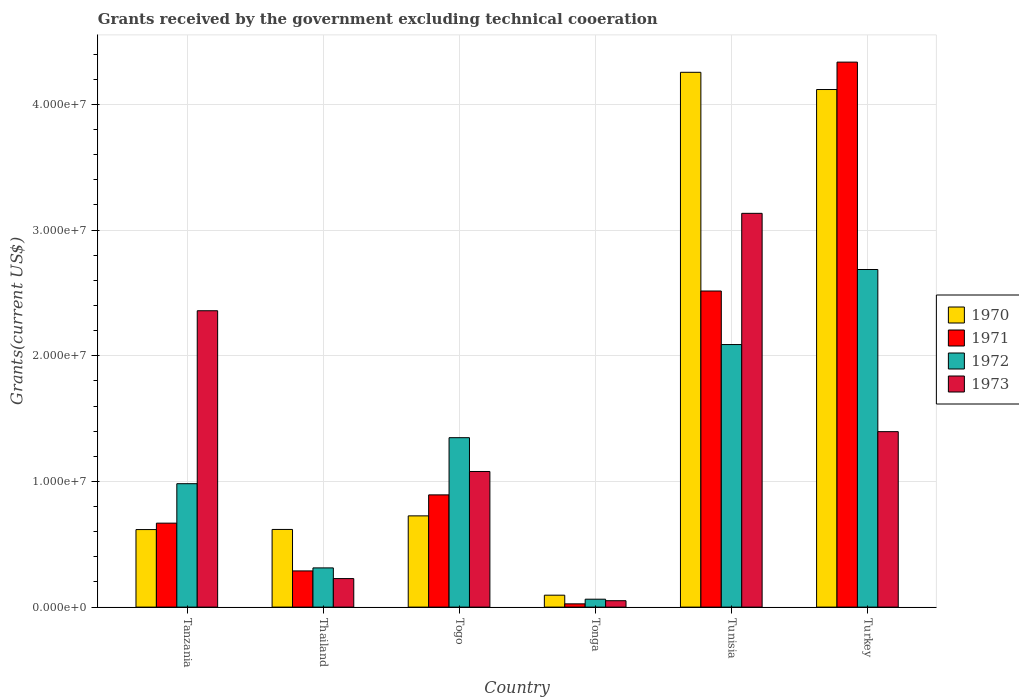How many groups of bars are there?
Your response must be concise. 6. Are the number of bars per tick equal to the number of legend labels?
Provide a short and direct response. Yes. What is the label of the 5th group of bars from the left?
Keep it short and to the point. Tunisia. What is the total grants received by the government in 1972 in Tunisia?
Your response must be concise. 2.09e+07. Across all countries, what is the maximum total grants received by the government in 1972?
Provide a succinct answer. 2.69e+07. Across all countries, what is the minimum total grants received by the government in 1970?
Your response must be concise. 9.50e+05. In which country was the total grants received by the government in 1970 minimum?
Provide a short and direct response. Tonga. What is the total total grants received by the government in 1972 in the graph?
Your response must be concise. 7.48e+07. What is the difference between the total grants received by the government in 1972 in Thailand and that in Tunisia?
Offer a very short reply. -1.78e+07. What is the difference between the total grants received by the government in 1973 in Tanzania and the total grants received by the government in 1972 in Togo?
Give a very brief answer. 1.01e+07. What is the average total grants received by the government in 1972 per country?
Offer a very short reply. 1.25e+07. What is the difference between the total grants received by the government of/in 1972 and total grants received by the government of/in 1971 in Turkey?
Your answer should be compact. -1.65e+07. What is the ratio of the total grants received by the government in 1972 in Tanzania to that in Togo?
Make the answer very short. 0.73. Is the total grants received by the government in 1972 in Thailand less than that in Tonga?
Provide a short and direct response. No. What is the difference between the highest and the second highest total grants received by the government in 1971?
Ensure brevity in your answer.  1.82e+07. What is the difference between the highest and the lowest total grants received by the government in 1971?
Provide a succinct answer. 4.31e+07. Is the sum of the total grants received by the government in 1972 in Tanzania and Turkey greater than the maximum total grants received by the government in 1973 across all countries?
Your answer should be very brief. Yes. Are all the bars in the graph horizontal?
Provide a succinct answer. No. What is the difference between two consecutive major ticks on the Y-axis?
Make the answer very short. 1.00e+07. Does the graph contain any zero values?
Your answer should be compact. No. Where does the legend appear in the graph?
Give a very brief answer. Center right. How many legend labels are there?
Ensure brevity in your answer.  4. How are the legend labels stacked?
Offer a terse response. Vertical. What is the title of the graph?
Offer a terse response. Grants received by the government excluding technical cooeration. What is the label or title of the Y-axis?
Your answer should be compact. Grants(current US$). What is the Grants(current US$) in 1970 in Tanzania?
Ensure brevity in your answer.  6.17e+06. What is the Grants(current US$) of 1971 in Tanzania?
Ensure brevity in your answer.  6.68e+06. What is the Grants(current US$) in 1972 in Tanzania?
Offer a very short reply. 9.82e+06. What is the Grants(current US$) of 1973 in Tanzania?
Your answer should be very brief. 2.36e+07. What is the Grants(current US$) in 1970 in Thailand?
Your response must be concise. 6.18e+06. What is the Grants(current US$) in 1971 in Thailand?
Make the answer very short. 2.88e+06. What is the Grants(current US$) in 1972 in Thailand?
Your answer should be very brief. 3.12e+06. What is the Grants(current US$) in 1973 in Thailand?
Keep it short and to the point. 2.27e+06. What is the Grants(current US$) of 1970 in Togo?
Make the answer very short. 7.26e+06. What is the Grants(current US$) of 1971 in Togo?
Give a very brief answer. 8.93e+06. What is the Grants(current US$) in 1972 in Togo?
Offer a terse response. 1.35e+07. What is the Grants(current US$) of 1973 in Togo?
Make the answer very short. 1.08e+07. What is the Grants(current US$) of 1970 in Tonga?
Make the answer very short. 9.50e+05. What is the Grants(current US$) of 1972 in Tonga?
Your answer should be very brief. 6.30e+05. What is the Grants(current US$) in 1973 in Tonga?
Ensure brevity in your answer.  5.10e+05. What is the Grants(current US$) of 1970 in Tunisia?
Your response must be concise. 4.26e+07. What is the Grants(current US$) of 1971 in Tunisia?
Offer a very short reply. 2.52e+07. What is the Grants(current US$) in 1972 in Tunisia?
Provide a short and direct response. 2.09e+07. What is the Grants(current US$) in 1973 in Tunisia?
Make the answer very short. 3.13e+07. What is the Grants(current US$) in 1970 in Turkey?
Make the answer very short. 4.12e+07. What is the Grants(current US$) of 1971 in Turkey?
Your answer should be very brief. 4.34e+07. What is the Grants(current US$) of 1972 in Turkey?
Your answer should be very brief. 2.69e+07. What is the Grants(current US$) of 1973 in Turkey?
Offer a very short reply. 1.40e+07. Across all countries, what is the maximum Grants(current US$) of 1970?
Your answer should be very brief. 4.26e+07. Across all countries, what is the maximum Grants(current US$) of 1971?
Your response must be concise. 4.34e+07. Across all countries, what is the maximum Grants(current US$) in 1972?
Make the answer very short. 2.69e+07. Across all countries, what is the maximum Grants(current US$) of 1973?
Offer a terse response. 3.13e+07. Across all countries, what is the minimum Grants(current US$) of 1970?
Keep it short and to the point. 9.50e+05. Across all countries, what is the minimum Grants(current US$) of 1971?
Make the answer very short. 2.60e+05. Across all countries, what is the minimum Grants(current US$) of 1972?
Provide a succinct answer. 6.30e+05. Across all countries, what is the minimum Grants(current US$) in 1973?
Your response must be concise. 5.10e+05. What is the total Grants(current US$) in 1970 in the graph?
Offer a very short reply. 1.04e+08. What is the total Grants(current US$) of 1971 in the graph?
Offer a terse response. 8.73e+07. What is the total Grants(current US$) of 1972 in the graph?
Make the answer very short. 7.48e+07. What is the total Grants(current US$) of 1973 in the graph?
Provide a succinct answer. 8.24e+07. What is the difference between the Grants(current US$) in 1970 in Tanzania and that in Thailand?
Your response must be concise. -10000. What is the difference between the Grants(current US$) of 1971 in Tanzania and that in Thailand?
Provide a short and direct response. 3.80e+06. What is the difference between the Grants(current US$) of 1972 in Tanzania and that in Thailand?
Offer a terse response. 6.70e+06. What is the difference between the Grants(current US$) of 1973 in Tanzania and that in Thailand?
Your response must be concise. 2.13e+07. What is the difference between the Grants(current US$) of 1970 in Tanzania and that in Togo?
Provide a succinct answer. -1.09e+06. What is the difference between the Grants(current US$) in 1971 in Tanzania and that in Togo?
Offer a terse response. -2.25e+06. What is the difference between the Grants(current US$) in 1972 in Tanzania and that in Togo?
Offer a terse response. -3.66e+06. What is the difference between the Grants(current US$) of 1973 in Tanzania and that in Togo?
Provide a short and direct response. 1.28e+07. What is the difference between the Grants(current US$) of 1970 in Tanzania and that in Tonga?
Offer a terse response. 5.22e+06. What is the difference between the Grants(current US$) of 1971 in Tanzania and that in Tonga?
Your answer should be compact. 6.42e+06. What is the difference between the Grants(current US$) of 1972 in Tanzania and that in Tonga?
Your response must be concise. 9.19e+06. What is the difference between the Grants(current US$) in 1973 in Tanzania and that in Tonga?
Offer a very short reply. 2.31e+07. What is the difference between the Grants(current US$) in 1970 in Tanzania and that in Tunisia?
Provide a succinct answer. -3.64e+07. What is the difference between the Grants(current US$) of 1971 in Tanzania and that in Tunisia?
Your answer should be very brief. -1.85e+07. What is the difference between the Grants(current US$) of 1972 in Tanzania and that in Tunisia?
Keep it short and to the point. -1.11e+07. What is the difference between the Grants(current US$) in 1973 in Tanzania and that in Tunisia?
Ensure brevity in your answer.  -7.75e+06. What is the difference between the Grants(current US$) in 1970 in Tanzania and that in Turkey?
Your answer should be compact. -3.50e+07. What is the difference between the Grants(current US$) of 1971 in Tanzania and that in Turkey?
Provide a succinct answer. -3.67e+07. What is the difference between the Grants(current US$) of 1972 in Tanzania and that in Turkey?
Your response must be concise. -1.70e+07. What is the difference between the Grants(current US$) in 1973 in Tanzania and that in Turkey?
Your response must be concise. 9.62e+06. What is the difference between the Grants(current US$) of 1970 in Thailand and that in Togo?
Make the answer very short. -1.08e+06. What is the difference between the Grants(current US$) in 1971 in Thailand and that in Togo?
Give a very brief answer. -6.05e+06. What is the difference between the Grants(current US$) in 1972 in Thailand and that in Togo?
Give a very brief answer. -1.04e+07. What is the difference between the Grants(current US$) of 1973 in Thailand and that in Togo?
Provide a short and direct response. -8.52e+06. What is the difference between the Grants(current US$) of 1970 in Thailand and that in Tonga?
Make the answer very short. 5.23e+06. What is the difference between the Grants(current US$) in 1971 in Thailand and that in Tonga?
Give a very brief answer. 2.62e+06. What is the difference between the Grants(current US$) of 1972 in Thailand and that in Tonga?
Provide a short and direct response. 2.49e+06. What is the difference between the Grants(current US$) in 1973 in Thailand and that in Tonga?
Your response must be concise. 1.76e+06. What is the difference between the Grants(current US$) in 1970 in Thailand and that in Tunisia?
Provide a short and direct response. -3.64e+07. What is the difference between the Grants(current US$) in 1971 in Thailand and that in Tunisia?
Your answer should be compact. -2.23e+07. What is the difference between the Grants(current US$) of 1972 in Thailand and that in Tunisia?
Keep it short and to the point. -1.78e+07. What is the difference between the Grants(current US$) of 1973 in Thailand and that in Tunisia?
Offer a terse response. -2.91e+07. What is the difference between the Grants(current US$) of 1970 in Thailand and that in Turkey?
Give a very brief answer. -3.50e+07. What is the difference between the Grants(current US$) of 1971 in Thailand and that in Turkey?
Your answer should be compact. -4.05e+07. What is the difference between the Grants(current US$) in 1972 in Thailand and that in Turkey?
Ensure brevity in your answer.  -2.37e+07. What is the difference between the Grants(current US$) of 1973 in Thailand and that in Turkey?
Your response must be concise. -1.17e+07. What is the difference between the Grants(current US$) of 1970 in Togo and that in Tonga?
Provide a short and direct response. 6.31e+06. What is the difference between the Grants(current US$) of 1971 in Togo and that in Tonga?
Your response must be concise. 8.67e+06. What is the difference between the Grants(current US$) of 1972 in Togo and that in Tonga?
Your answer should be compact. 1.28e+07. What is the difference between the Grants(current US$) of 1973 in Togo and that in Tonga?
Make the answer very short. 1.03e+07. What is the difference between the Grants(current US$) in 1970 in Togo and that in Tunisia?
Provide a short and direct response. -3.53e+07. What is the difference between the Grants(current US$) in 1971 in Togo and that in Tunisia?
Offer a terse response. -1.62e+07. What is the difference between the Grants(current US$) of 1972 in Togo and that in Tunisia?
Ensure brevity in your answer.  -7.41e+06. What is the difference between the Grants(current US$) in 1973 in Togo and that in Tunisia?
Offer a very short reply. -2.05e+07. What is the difference between the Grants(current US$) in 1970 in Togo and that in Turkey?
Make the answer very short. -3.39e+07. What is the difference between the Grants(current US$) of 1971 in Togo and that in Turkey?
Your answer should be compact. -3.44e+07. What is the difference between the Grants(current US$) of 1972 in Togo and that in Turkey?
Make the answer very short. -1.34e+07. What is the difference between the Grants(current US$) of 1973 in Togo and that in Turkey?
Your answer should be compact. -3.17e+06. What is the difference between the Grants(current US$) in 1970 in Tonga and that in Tunisia?
Offer a terse response. -4.16e+07. What is the difference between the Grants(current US$) in 1971 in Tonga and that in Tunisia?
Your answer should be very brief. -2.49e+07. What is the difference between the Grants(current US$) of 1972 in Tonga and that in Tunisia?
Offer a terse response. -2.03e+07. What is the difference between the Grants(current US$) in 1973 in Tonga and that in Tunisia?
Your answer should be very brief. -3.08e+07. What is the difference between the Grants(current US$) of 1970 in Tonga and that in Turkey?
Provide a succinct answer. -4.02e+07. What is the difference between the Grants(current US$) of 1971 in Tonga and that in Turkey?
Ensure brevity in your answer.  -4.31e+07. What is the difference between the Grants(current US$) in 1972 in Tonga and that in Turkey?
Offer a terse response. -2.62e+07. What is the difference between the Grants(current US$) in 1973 in Tonga and that in Turkey?
Give a very brief answer. -1.34e+07. What is the difference between the Grants(current US$) of 1970 in Tunisia and that in Turkey?
Provide a short and direct response. 1.37e+06. What is the difference between the Grants(current US$) in 1971 in Tunisia and that in Turkey?
Provide a short and direct response. -1.82e+07. What is the difference between the Grants(current US$) in 1972 in Tunisia and that in Turkey?
Provide a short and direct response. -5.97e+06. What is the difference between the Grants(current US$) of 1973 in Tunisia and that in Turkey?
Make the answer very short. 1.74e+07. What is the difference between the Grants(current US$) of 1970 in Tanzania and the Grants(current US$) of 1971 in Thailand?
Give a very brief answer. 3.29e+06. What is the difference between the Grants(current US$) of 1970 in Tanzania and the Grants(current US$) of 1972 in Thailand?
Your answer should be very brief. 3.05e+06. What is the difference between the Grants(current US$) in 1970 in Tanzania and the Grants(current US$) in 1973 in Thailand?
Offer a terse response. 3.90e+06. What is the difference between the Grants(current US$) of 1971 in Tanzania and the Grants(current US$) of 1972 in Thailand?
Your response must be concise. 3.56e+06. What is the difference between the Grants(current US$) of 1971 in Tanzania and the Grants(current US$) of 1973 in Thailand?
Offer a terse response. 4.41e+06. What is the difference between the Grants(current US$) in 1972 in Tanzania and the Grants(current US$) in 1973 in Thailand?
Offer a terse response. 7.55e+06. What is the difference between the Grants(current US$) of 1970 in Tanzania and the Grants(current US$) of 1971 in Togo?
Provide a short and direct response. -2.76e+06. What is the difference between the Grants(current US$) of 1970 in Tanzania and the Grants(current US$) of 1972 in Togo?
Make the answer very short. -7.31e+06. What is the difference between the Grants(current US$) of 1970 in Tanzania and the Grants(current US$) of 1973 in Togo?
Your answer should be compact. -4.62e+06. What is the difference between the Grants(current US$) of 1971 in Tanzania and the Grants(current US$) of 1972 in Togo?
Offer a very short reply. -6.80e+06. What is the difference between the Grants(current US$) in 1971 in Tanzania and the Grants(current US$) in 1973 in Togo?
Your answer should be very brief. -4.11e+06. What is the difference between the Grants(current US$) of 1972 in Tanzania and the Grants(current US$) of 1973 in Togo?
Offer a very short reply. -9.70e+05. What is the difference between the Grants(current US$) of 1970 in Tanzania and the Grants(current US$) of 1971 in Tonga?
Your response must be concise. 5.91e+06. What is the difference between the Grants(current US$) of 1970 in Tanzania and the Grants(current US$) of 1972 in Tonga?
Make the answer very short. 5.54e+06. What is the difference between the Grants(current US$) of 1970 in Tanzania and the Grants(current US$) of 1973 in Tonga?
Give a very brief answer. 5.66e+06. What is the difference between the Grants(current US$) in 1971 in Tanzania and the Grants(current US$) in 1972 in Tonga?
Offer a very short reply. 6.05e+06. What is the difference between the Grants(current US$) of 1971 in Tanzania and the Grants(current US$) of 1973 in Tonga?
Ensure brevity in your answer.  6.17e+06. What is the difference between the Grants(current US$) in 1972 in Tanzania and the Grants(current US$) in 1973 in Tonga?
Offer a terse response. 9.31e+06. What is the difference between the Grants(current US$) of 1970 in Tanzania and the Grants(current US$) of 1971 in Tunisia?
Your response must be concise. -1.90e+07. What is the difference between the Grants(current US$) of 1970 in Tanzania and the Grants(current US$) of 1972 in Tunisia?
Make the answer very short. -1.47e+07. What is the difference between the Grants(current US$) of 1970 in Tanzania and the Grants(current US$) of 1973 in Tunisia?
Offer a terse response. -2.52e+07. What is the difference between the Grants(current US$) of 1971 in Tanzania and the Grants(current US$) of 1972 in Tunisia?
Offer a very short reply. -1.42e+07. What is the difference between the Grants(current US$) of 1971 in Tanzania and the Grants(current US$) of 1973 in Tunisia?
Your answer should be compact. -2.46e+07. What is the difference between the Grants(current US$) of 1972 in Tanzania and the Grants(current US$) of 1973 in Tunisia?
Your answer should be compact. -2.15e+07. What is the difference between the Grants(current US$) in 1970 in Tanzania and the Grants(current US$) in 1971 in Turkey?
Your response must be concise. -3.72e+07. What is the difference between the Grants(current US$) in 1970 in Tanzania and the Grants(current US$) in 1972 in Turkey?
Give a very brief answer. -2.07e+07. What is the difference between the Grants(current US$) in 1970 in Tanzania and the Grants(current US$) in 1973 in Turkey?
Offer a terse response. -7.79e+06. What is the difference between the Grants(current US$) of 1971 in Tanzania and the Grants(current US$) of 1972 in Turkey?
Offer a very short reply. -2.02e+07. What is the difference between the Grants(current US$) in 1971 in Tanzania and the Grants(current US$) in 1973 in Turkey?
Provide a succinct answer. -7.28e+06. What is the difference between the Grants(current US$) of 1972 in Tanzania and the Grants(current US$) of 1973 in Turkey?
Offer a very short reply. -4.14e+06. What is the difference between the Grants(current US$) of 1970 in Thailand and the Grants(current US$) of 1971 in Togo?
Your answer should be compact. -2.75e+06. What is the difference between the Grants(current US$) of 1970 in Thailand and the Grants(current US$) of 1972 in Togo?
Your answer should be compact. -7.30e+06. What is the difference between the Grants(current US$) of 1970 in Thailand and the Grants(current US$) of 1973 in Togo?
Provide a short and direct response. -4.61e+06. What is the difference between the Grants(current US$) of 1971 in Thailand and the Grants(current US$) of 1972 in Togo?
Your response must be concise. -1.06e+07. What is the difference between the Grants(current US$) in 1971 in Thailand and the Grants(current US$) in 1973 in Togo?
Your answer should be compact. -7.91e+06. What is the difference between the Grants(current US$) in 1972 in Thailand and the Grants(current US$) in 1973 in Togo?
Make the answer very short. -7.67e+06. What is the difference between the Grants(current US$) of 1970 in Thailand and the Grants(current US$) of 1971 in Tonga?
Make the answer very short. 5.92e+06. What is the difference between the Grants(current US$) in 1970 in Thailand and the Grants(current US$) in 1972 in Tonga?
Provide a short and direct response. 5.55e+06. What is the difference between the Grants(current US$) in 1970 in Thailand and the Grants(current US$) in 1973 in Tonga?
Your answer should be very brief. 5.67e+06. What is the difference between the Grants(current US$) in 1971 in Thailand and the Grants(current US$) in 1972 in Tonga?
Offer a very short reply. 2.25e+06. What is the difference between the Grants(current US$) of 1971 in Thailand and the Grants(current US$) of 1973 in Tonga?
Provide a short and direct response. 2.37e+06. What is the difference between the Grants(current US$) of 1972 in Thailand and the Grants(current US$) of 1973 in Tonga?
Your answer should be very brief. 2.61e+06. What is the difference between the Grants(current US$) in 1970 in Thailand and the Grants(current US$) in 1971 in Tunisia?
Ensure brevity in your answer.  -1.90e+07. What is the difference between the Grants(current US$) of 1970 in Thailand and the Grants(current US$) of 1972 in Tunisia?
Make the answer very short. -1.47e+07. What is the difference between the Grants(current US$) of 1970 in Thailand and the Grants(current US$) of 1973 in Tunisia?
Provide a short and direct response. -2.52e+07. What is the difference between the Grants(current US$) in 1971 in Thailand and the Grants(current US$) in 1972 in Tunisia?
Offer a very short reply. -1.80e+07. What is the difference between the Grants(current US$) in 1971 in Thailand and the Grants(current US$) in 1973 in Tunisia?
Your answer should be compact. -2.84e+07. What is the difference between the Grants(current US$) in 1972 in Thailand and the Grants(current US$) in 1973 in Tunisia?
Give a very brief answer. -2.82e+07. What is the difference between the Grants(current US$) in 1970 in Thailand and the Grants(current US$) in 1971 in Turkey?
Keep it short and to the point. -3.72e+07. What is the difference between the Grants(current US$) in 1970 in Thailand and the Grants(current US$) in 1972 in Turkey?
Your response must be concise. -2.07e+07. What is the difference between the Grants(current US$) of 1970 in Thailand and the Grants(current US$) of 1973 in Turkey?
Provide a succinct answer. -7.78e+06. What is the difference between the Grants(current US$) of 1971 in Thailand and the Grants(current US$) of 1972 in Turkey?
Make the answer very short. -2.40e+07. What is the difference between the Grants(current US$) in 1971 in Thailand and the Grants(current US$) in 1973 in Turkey?
Give a very brief answer. -1.11e+07. What is the difference between the Grants(current US$) in 1972 in Thailand and the Grants(current US$) in 1973 in Turkey?
Offer a very short reply. -1.08e+07. What is the difference between the Grants(current US$) of 1970 in Togo and the Grants(current US$) of 1971 in Tonga?
Your answer should be very brief. 7.00e+06. What is the difference between the Grants(current US$) in 1970 in Togo and the Grants(current US$) in 1972 in Tonga?
Ensure brevity in your answer.  6.63e+06. What is the difference between the Grants(current US$) of 1970 in Togo and the Grants(current US$) of 1973 in Tonga?
Your answer should be very brief. 6.75e+06. What is the difference between the Grants(current US$) of 1971 in Togo and the Grants(current US$) of 1972 in Tonga?
Offer a terse response. 8.30e+06. What is the difference between the Grants(current US$) in 1971 in Togo and the Grants(current US$) in 1973 in Tonga?
Your response must be concise. 8.42e+06. What is the difference between the Grants(current US$) of 1972 in Togo and the Grants(current US$) of 1973 in Tonga?
Provide a short and direct response. 1.30e+07. What is the difference between the Grants(current US$) in 1970 in Togo and the Grants(current US$) in 1971 in Tunisia?
Give a very brief answer. -1.79e+07. What is the difference between the Grants(current US$) in 1970 in Togo and the Grants(current US$) in 1972 in Tunisia?
Offer a very short reply. -1.36e+07. What is the difference between the Grants(current US$) in 1970 in Togo and the Grants(current US$) in 1973 in Tunisia?
Provide a short and direct response. -2.41e+07. What is the difference between the Grants(current US$) of 1971 in Togo and the Grants(current US$) of 1972 in Tunisia?
Keep it short and to the point. -1.20e+07. What is the difference between the Grants(current US$) of 1971 in Togo and the Grants(current US$) of 1973 in Tunisia?
Ensure brevity in your answer.  -2.24e+07. What is the difference between the Grants(current US$) of 1972 in Togo and the Grants(current US$) of 1973 in Tunisia?
Your answer should be very brief. -1.78e+07. What is the difference between the Grants(current US$) in 1970 in Togo and the Grants(current US$) in 1971 in Turkey?
Provide a short and direct response. -3.61e+07. What is the difference between the Grants(current US$) of 1970 in Togo and the Grants(current US$) of 1972 in Turkey?
Ensure brevity in your answer.  -1.96e+07. What is the difference between the Grants(current US$) in 1970 in Togo and the Grants(current US$) in 1973 in Turkey?
Ensure brevity in your answer.  -6.70e+06. What is the difference between the Grants(current US$) in 1971 in Togo and the Grants(current US$) in 1972 in Turkey?
Give a very brief answer. -1.79e+07. What is the difference between the Grants(current US$) in 1971 in Togo and the Grants(current US$) in 1973 in Turkey?
Offer a very short reply. -5.03e+06. What is the difference between the Grants(current US$) of 1972 in Togo and the Grants(current US$) of 1973 in Turkey?
Keep it short and to the point. -4.80e+05. What is the difference between the Grants(current US$) of 1970 in Tonga and the Grants(current US$) of 1971 in Tunisia?
Make the answer very short. -2.42e+07. What is the difference between the Grants(current US$) of 1970 in Tonga and the Grants(current US$) of 1972 in Tunisia?
Make the answer very short. -1.99e+07. What is the difference between the Grants(current US$) of 1970 in Tonga and the Grants(current US$) of 1973 in Tunisia?
Make the answer very short. -3.04e+07. What is the difference between the Grants(current US$) in 1971 in Tonga and the Grants(current US$) in 1972 in Tunisia?
Ensure brevity in your answer.  -2.06e+07. What is the difference between the Grants(current US$) of 1971 in Tonga and the Grants(current US$) of 1973 in Tunisia?
Offer a very short reply. -3.11e+07. What is the difference between the Grants(current US$) in 1972 in Tonga and the Grants(current US$) in 1973 in Tunisia?
Provide a succinct answer. -3.07e+07. What is the difference between the Grants(current US$) of 1970 in Tonga and the Grants(current US$) of 1971 in Turkey?
Your response must be concise. -4.24e+07. What is the difference between the Grants(current US$) of 1970 in Tonga and the Grants(current US$) of 1972 in Turkey?
Offer a terse response. -2.59e+07. What is the difference between the Grants(current US$) of 1970 in Tonga and the Grants(current US$) of 1973 in Turkey?
Your response must be concise. -1.30e+07. What is the difference between the Grants(current US$) in 1971 in Tonga and the Grants(current US$) in 1972 in Turkey?
Make the answer very short. -2.66e+07. What is the difference between the Grants(current US$) of 1971 in Tonga and the Grants(current US$) of 1973 in Turkey?
Your answer should be very brief. -1.37e+07. What is the difference between the Grants(current US$) in 1972 in Tonga and the Grants(current US$) in 1973 in Turkey?
Ensure brevity in your answer.  -1.33e+07. What is the difference between the Grants(current US$) of 1970 in Tunisia and the Grants(current US$) of 1971 in Turkey?
Your answer should be very brief. -8.10e+05. What is the difference between the Grants(current US$) of 1970 in Tunisia and the Grants(current US$) of 1972 in Turkey?
Offer a terse response. 1.57e+07. What is the difference between the Grants(current US$) of 1970 in Tunisia and the Grants(current US$) of 1973 in Turkey?
Offer a terse response. 2.86e+07. What is the difference between the Grants(current US$) of 1971 in Tunisia and the Grants(current US$) of 1972 in Turkey?
Your response must be concise. -1.71e+06. What is the difference between the Grants(current US$) of 1971 in Tunisia and the Grants(current US$) of 1973 in Turkey?
Offer a very short reply. 1.12e+07. What is the difference between the Grants(current US$) in 1972 in Tunisia and the Grants(current US$) in 1973 in Turkey?
Your answer should be very brief. 6.93e+06. What is the average Grants(current US$) in 1970 per country?
Keep it short and to the point. 1.74e+07. What is the average Grants(current US$) in 1971 per country?
Give a very brief answer. 1.45e+07. What is the average Grants(current US$) in 1972 per country?
Your answer should be very brief. 1.25e+07. What is the average Grants(current US$) of 1973 per country?
Your response must be concise. 1.37e+07. What is the difference between the Grants(current US$) in 1970 and Grants(current US$) in 1971 in Tanzania?
Your response must be concise. -5.10e+05. What is the difference between the Grants(current US$) of 1970 and Grants(current US$) of 1972 in Tanzania?
Keep it short and to the point. -3.65e+06. What is the difference between the Grants(current US$) in 1970 and Grants(current US$) in 1973 in Tanzania?
Ensure brevity in your answer.  -1.74e+07. What is the difference between the Grants(current US$) of 1971 and Grants(current US$) of 1972 in Tanzania?
Give a very brief answer. -3.14e+06. What is the difference between the Grants(current US$) in 1971 and Grants(current US$) in 1973 in Tanzania?
Your answer should be compact. -1.69e+07. What is the difference between the Grants(current US$) in 1972 and Grants(current US$) in 1973 in Tanzania?
Provide a succinct answer. -1.38e+07. What is the difference between the Grants(current US$) of 1970 and Grants(current US$) of 1971 in Thailand?
Your answer should be compact. 3.30e+06. What is the difference between the Grants(current US$) of 1970 and Grants(current US$) of 1972 in Thailand?
Your response must be concise. 3.06e+06. What is the difference between the Grants(current US$) in 1970 and Grants(current US$) in 1973 in Thailand?
Your answer should be very brief. 3.91e+06. What is the difference between the Grants(current US$) of 1972 and Grants(current US$) of 1973 in Thailand?
Offer a very short reply. 8.50e+05. What is the difference between the Grants(current US$) in 1970 and Grants(current US$) in 1971 in Togo?
Your answer should be compact. -1.67e+06. What is the difference between the Grants(current US$) of 1970 and Grants(current US$) of 1972 in Togo?
Keep it short and to the point. -6.22e+06. What is the difference between the Grants(current US$) of 1970 and Grants(current US$) of 1973 in Togo?
Offer a very short reply. -3.53e+06. What is the difference between the Grants(current US$) in 1971 and Grants(current US$) in 1972 in Togo?
Keep it short and to the point. -4.55e+06. What is the difference between the Grants(current US$) of 1971 and Grants(current US$) of 1973 in Togo?
Make the answer very short. -1.86e+06. What is the difference between the Grants(current US$) of 1972 and Grants(current US$) of 1973 in Togo?
Offer a very short reply. 2.69e+06. What is the difference between the Grants(current US$) of 1970 and Grants(current US$) of 1971 in Tonga?
Provide a short and direct response. 6.90e+05. What is the difference between the Grants(current US$) of 1970 and Grants(current US$) of 1973 in Tonga?
Give a very brief answer. 4.40e+05. What is the difference between the Grants(current US$) in 1971 and Grants(current US$) in 1972 in Tonga?
Keep it short and to the point. -3.70e+05. What is the difference between the Grants(current US$) in 1971 and Grants(current US$) in 1973 in Tonga?
Offer a very short reply. -2.50e+05. What is the difference between the Grants(current US$) in 1972 and Grants(current US$) in 1973 in Tonga?
Your response must be concise. 1.20e+05. What is the difference between the Grants(current US$) in 1970 and Grants(current US$) in 1971 in Tunisia?
Offer a very short reply. 1.74e+07. What is the difference between the Grants(current US$) of 1970 and Grants(current US$) of 1972 in Tunisia?
Ensure brevity in your answer.  2.17e+07. What is the difference between the Grants(current US$) of 1970 and Grants(current US$) of 1973 in Tunisia?
Ensure brevity in your answer.  1.12e+07. What is the difference between the Grants(current US$) of 1971 and Grants(current US$) of 1972 in Tunisia?
Give a very brief answer. 4.26e+06. What is the difference between the Grants(current US$) in 1971 and Grants(current US$) in 1973 in Tunisia?
Your answer should be compact. -6.18e+06. What is the difference between the Grants(current US$) in 1972 and Grants(current US$) in 1973 in Tunisia?
Offer a very short reply. -1.04e+07. What is the difference between the Grants(current US$) of 1970 and Grants(current US$) of 1971 in Turkey?
Offer a terse response. -2.18e+06. What is the difference between the Grants(current US$) of 1970 and Grants(current US$) of 1972 in Turkey?
Ensure brevity in your answer.  1.43e+07. What is the difference between the Grants(current US$) in 1970 and Grants(current US$) in 1973 in Turkey?
Your response must be concise. 2.72e+07. What is the difference between the Grants(current US$) in 1971 and Grants(current US$) in 1972 in Turkey?
Your answer should be very brief. 1.65e+07. What is the difference between the Grants(current US$) of 1971 and Grants(current US$) of 1973 in Turkey?
Ensure brevity in your answer.  2.94e+07. What is the difference between the Grants(current US$) of 1972 and Grants(current US$) of 1973 in Turkey?
Provide a short and direct response. 1.29e+07. What is the ratio of the Grants(current US$) in 1971 in Tanzania to that in Thailand?
Ensure brevity in your answer.  2.32. What is the ratio of the Grants(current US$) of 1972 in Tanzania to that in Thailand?
Make the answer very short. 3.15. What is the ratio of the Grants(current US$) of 1973 in Tanzania to that in Thailand?
Your answer should be compact. 10.39. What is the ratio of the Grants(current US$) of 1970 in Tanzania to that in Togo?
Provide a short and direct response. 0.85. What is the ratio of the Grants(current US$) of 1971 in Tanzania to that in Togo?
Offer a terse response. 0.75. What is the ratio of the Grants(current US$) in 1972 in Tanzania to that in Togo?
Offer a very short reply. 0.73. What is the ratio of the Grants(current US$) of 1973 in Tanzania to that in Togo?
Make the answer very short. 2.19. What is the ratio of the Grants(current US$) of 1970 in Tanzania to that in Tonga?
Your answer should be very brief. 6.49. What is the ratio of the Grants(current US$) of 1971 in Tanzania to that in Tonga?
Provide a short and direct response. 25.69. What is the ratio of the Grants(current US$) in 1972 in Tanzania to that in Tonga?
Your answer should be compact. 15.59. What is the ratio of the Grants(current US$) of 1973 in Tanzania to that in Tonga?
Your answer should be very brief. 46.24. What is the ratio of the Grants(current US$) of 1970 in Tanzania to that in Tunisia?
Offer a terse response. 0.14. What is the ratio of the Grants(current US$) of 1971 in Tanzania to that in Tunisia?
Offer a very short reply. 0.27. What is the ratio of the Grants(current US$) of 1972 in Tanzania to that in Tunisia?
Your answer should be compact. 0.47. What is the ratio of the Grants(current US$) of 1973 in Tanzania to that in Tunisia?
Your response must be concise. 0.75. What is the ratio of the Grants(current US$) in 1970 in Tanzania to that in Turkey?
Your answer should be very brief. 0.15. What is the ratio of the Grants(current US$) in 1971 in Tanzania to that in Turkey?
Your response must be concise. 0.15. What is the ratio of the Grants(current US$) in 1972 in Tanzania to that in Turkey?
Your answer should be compact. 0.37. What is the ratio of the Grants(current US$) of 1973 in Tanzania to that in Turkey?
Your response must be concise. 1.69. What is the ratio of the Grants(current US$) of 1970 in Thailand to that in Togo?
Ensure brevity in your answer.  0.85. What is the ratio of the Grants(current US$) in 1971 in Thailand to that in Togo?
Offer a terse response. 0.32. What is the ratio of the Grants(current US$) in 1972 in Thailand to that in Togo?
Keep it short and to the point. 0.23. What is the ratio of the Grants(current US$) of 1973 in Thailand to that in Togo?
Your answer should be very brief. 0.21. What is the ratio of the Grants(current US$) of 1970 in Thailand to that in Tonga?
Your answer should be very brief. 6.51. What is the ratio of the Grants(current US$) in 1971 in Thailand to that in Tonga?
Make the answer very short. 11.08. What is the ratio of the Grants(current US$) of 1972 in Thailand to that in Tonga?
Your answer should be compact. 4.95. What is the ratio of the Grants(current US$) in 1973 in Thailand to that in Tonga?
Make the answer very short. 4.45. What is the ratio of the Grants(current US$) of 1970 in Thailand to that in Tunisia?
Your answer should be very brief. 0.15. What is the ratio of the Grants(current US$) of 1971 in Thailand to that in Tunisia?
Give a very brief answer. 0.11. What is the ratio of the Grants(current US$) of 1972 in Thailand to that in Tunisia?
Your answer should be very brief. 0.15. What is the ratio of the Grants(current US$) of 1973 in Thailand to that in Tunisia?
Provide a succinct answer. 0.07. What is the ratio of the Grants(current US$) of 1970 in Thailand to that in Turkey?
Your answer should be compact. 0.15. What is the ratio of the Grants(current US$) in 1971 in Thailand to that in Turkey?
Your answer should be very brief. 0.07. What is the ratio of the Grants(current US$) of 1972 in Thailand to that in Turkey?
Ensure brevity in your answer.  0.12. What is the ratio of the Grants(current US$) of 1973 in Thailand to that in Turkey?
Keep it short and to the point. 0.16. What is the ratio of the Grants(current US$) of 1970 in Togo to that in Tonga?
Your answer should be compact. 7.64. What is the ratio of the Grants(current US$) of 1971 in Togo to that in Tonga?
Offer a terse response. 34.35. What is the ratio of the Grants(current US$) of 1972 in Togo to that in Tonga?
Keep it short and to the point. 21.4. What is the ratio of the Grants(current US$) in 1973 in Togo to that in Tonga?
Ensure brevity in your answer.  21.16. What is the ratio of the Grants(current US$) in 1970 in Togo to that in Tunisia?
Give a very brief answer. 0.17. What is the ratio of the Grants(current US$) of 1971 in Togo to that in Tunisia?
Offer a terse response. 0.36. What is the ratio of the Grants(current US$) in 1972 in Togo to that in Tunisia?
Your response must be concise. 0.65. What is the ratio of the Grants(current US$) of 1973 in Togo to that in Tunisia?
Provide a succinct answer. 0.34. What is the ratio of the Grants(current US$) of 1970 in Togo to that in Turkey?
Provide a short and direct response. 0.18. What is the ratio of the Grants(current US$) in 1971 in Togo to that in Turkey?
Offer a terse response. 0.21. What is the ratio of the Grants(current US$) in 1972 in Togo to that in Turkey?
Give a very brief answer. 0.5. What is the ratio of the Grants(current US$) in 1973 in Togo to that in Turkey?
Keep it short and to the point. 0.77. What is the ratio of the Grants(current US$) in 1970 in Tonga to that in Tunisia?
Give a very brief answer. 0.02. What is the ratio of the Grants(current US$) in 1971 in Tonga to that in Tunisia?
Provide a succinct answer. 0.01. What is the ratio of the Grants(current US$) of 1972 in Tonga to that in Tunisia?
Ensure brevity in your answer.  0.03. What is the ratio of the Grants(current US$) in 1973 in Tonga to that in Tunisia?
Offer a terse response. 0.02. What is the ratio of the Grants(current US$) in 1970 in Tonga to that in Turkey?
Give a very brief answer. 0.02. What is the ratio of the Grants(current US$) of 1971 in Tonga to that in Turkey?
Your answer should be compact. 0.01. What is the ratio of the Grants(current US$) of 1972 in Tonga to that in Turkey?
Give a very brief answer. 0.02. What is the ratio of the Grants(current US$) in 1973 in Tonga to that in Turkey?
Your response must be concise. 0.04. What is the ratio of the Grants(current US$) in 1970 in Tunisia to that in Turkey?
Make the answer very short. 1.03. What is the ratio of the Grants(current US$) in 1971 in Tunisia to that in Turkey?
Your answer should be very brief. 0.58. What is the ratio of the Grants(current US$) of 1972 in Tunisia to that in Turkey?
Make the answer very short. 0.78. What is the ratio of the Grants(current US$) in 1973 in Tunisia to that in Turkey?
Your response must be concise. 2.24. What is the difference between the highest and the second highest Grants(current US$) in 1970?
Give a very brief answer. 1.37e+06. What is the difference between the highest and the second highest Grants(current US$) of 1971?
Keep it short and to the point. 1.82e+07. What is the difference between the highest and the second highest Grants(current US$) in 1972?
Your answer should be very brief. 5.97e+06. What is the difference between the highest and the second highest Grants(current US$) in 1973?
Keep it short and to the point. 7.75e+06. What is the difference between the highest and the lowest Grants(current US$) in 1970?
Offer a terse response. 4.16e+07. What is the difference between the highest and the lowest Grants(current US$) in 1971?
Provide a succinct answer. 4.31e+07. What is the difference between the highest and the lowest Grants(current US$) of 1972?
Give a very brief answer. 2.62e+07. What is the difference between the highest and the lowest Grants(current US$) in 1973?
Give a very brief answer. 3.08e+07. 